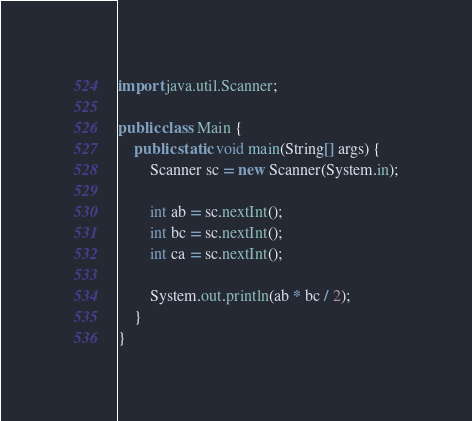Convert code to text. <code><loc_0><loc_0><loc_500><loc_500><_Java_>import java.util.Scanner;

public class Main {
    public static void main(String[] args) {
        Scanner sc = new Scanner(System.in);

        int ab = sc.nextInt();
        int bc = sc.nextInt();
        int ca = sc.nextInt();
        
        System.out.println(ab * bc / 2);
    }
}
</code> 